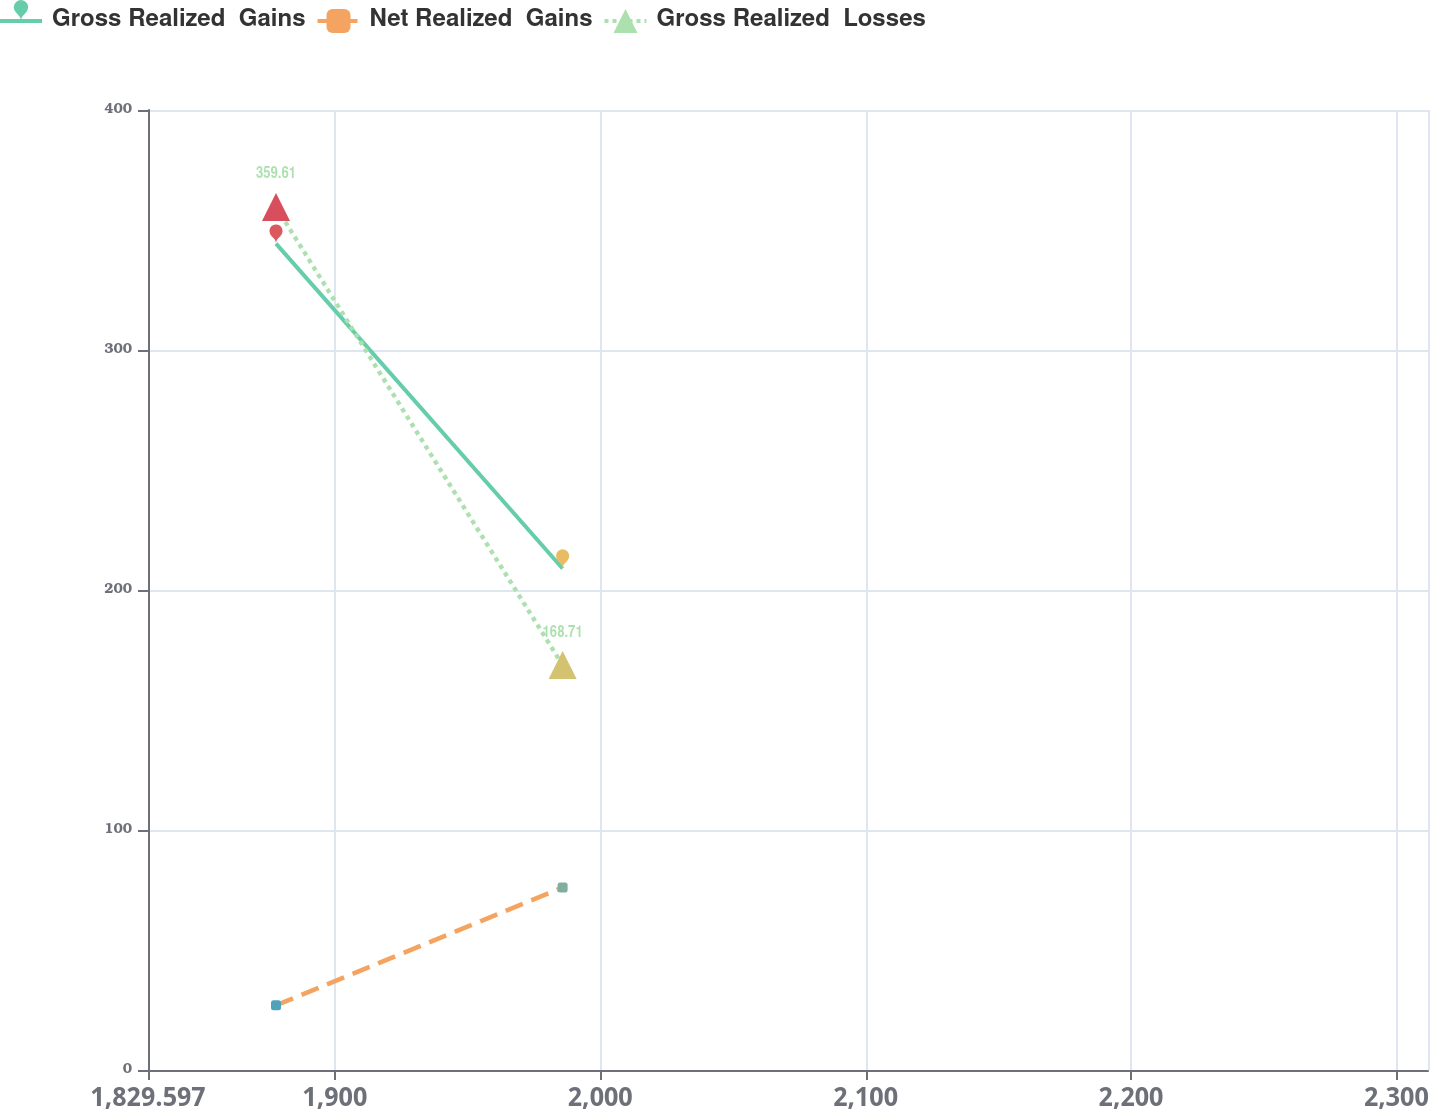Convert chart to OTSL. <chart><loc_0><loc_0><loc_500><loc_500><line_chart><ecel><fcel>Gross Realized  Gains<fcel>Net Realized  Gains<fcel>Gross Realized  Losses<nl><fcel>1877.83<fcel>344.34<fcel>26.97<fcel>359.61<nl><fcel>1985.83<fcel>208.95<fcel>76.05<fcel>168.71<nl><fcel>2360.16<fcel>231.44<fcel>130.91<fcel>147.5<nl></chart> 